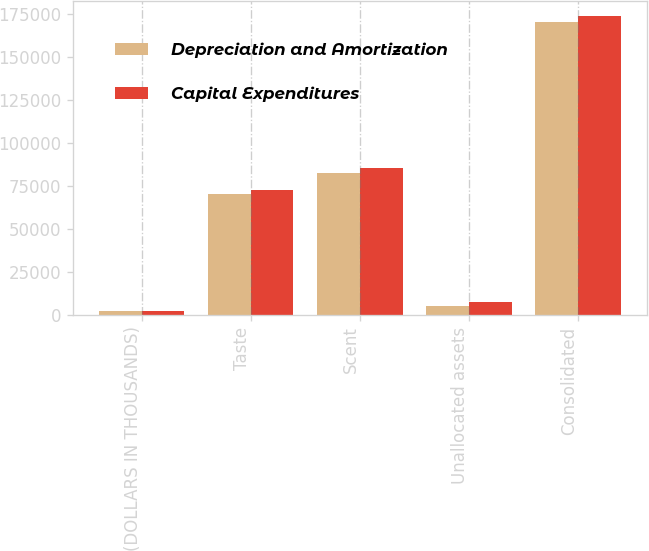Convert chart to OTSL. <chart><loc_0><loc_0><loc_500><loc_500><stacked_bar_chart><ecel><fcel>(DOLLARS IN THOUSANDS)<fcel>Taste<fcel>Scent<fcel>Unallocated assets<fcel>Consolidated<nl><fcel>Depreciation and Amortization<fcel>2018<fcel>70028<fcel>82206<fcel>4982<fcel>170094<nl><fcel>Capital Expenditures<fcel>2018<fcel>72474<fcel>85078<fcel>7502<fcel>173792<nl></chart> 